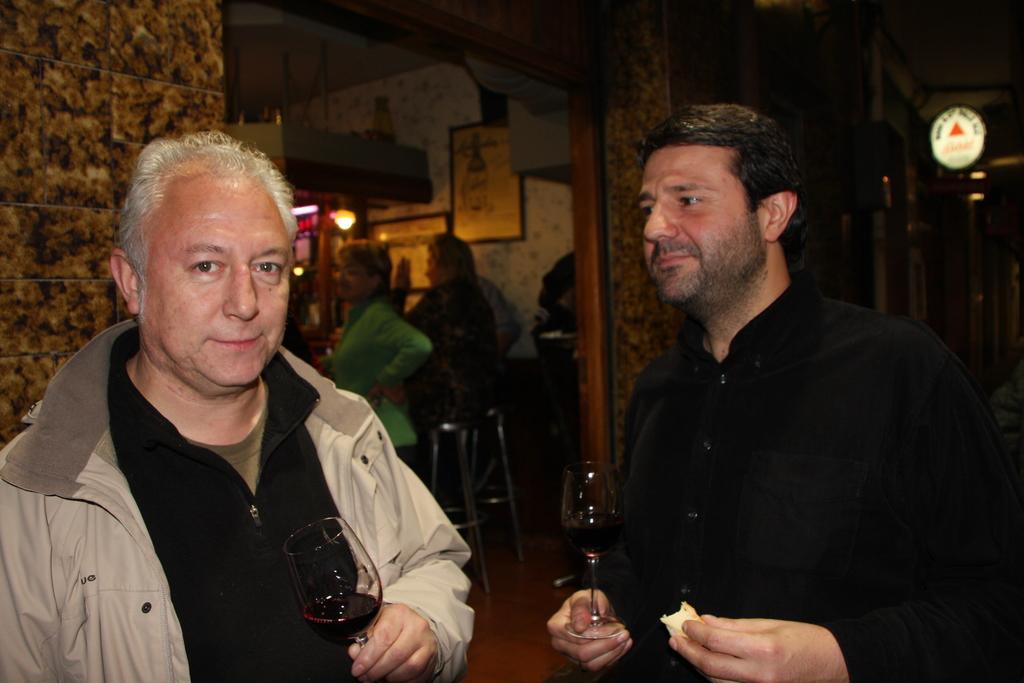Could you give a brief overview of what you see in this image? As we can see in the image there is a wall, photo frame, chairs and few people here and there. The man on the right side is wearing black color shirt and the man on the left side is wearing grey color jacket. 